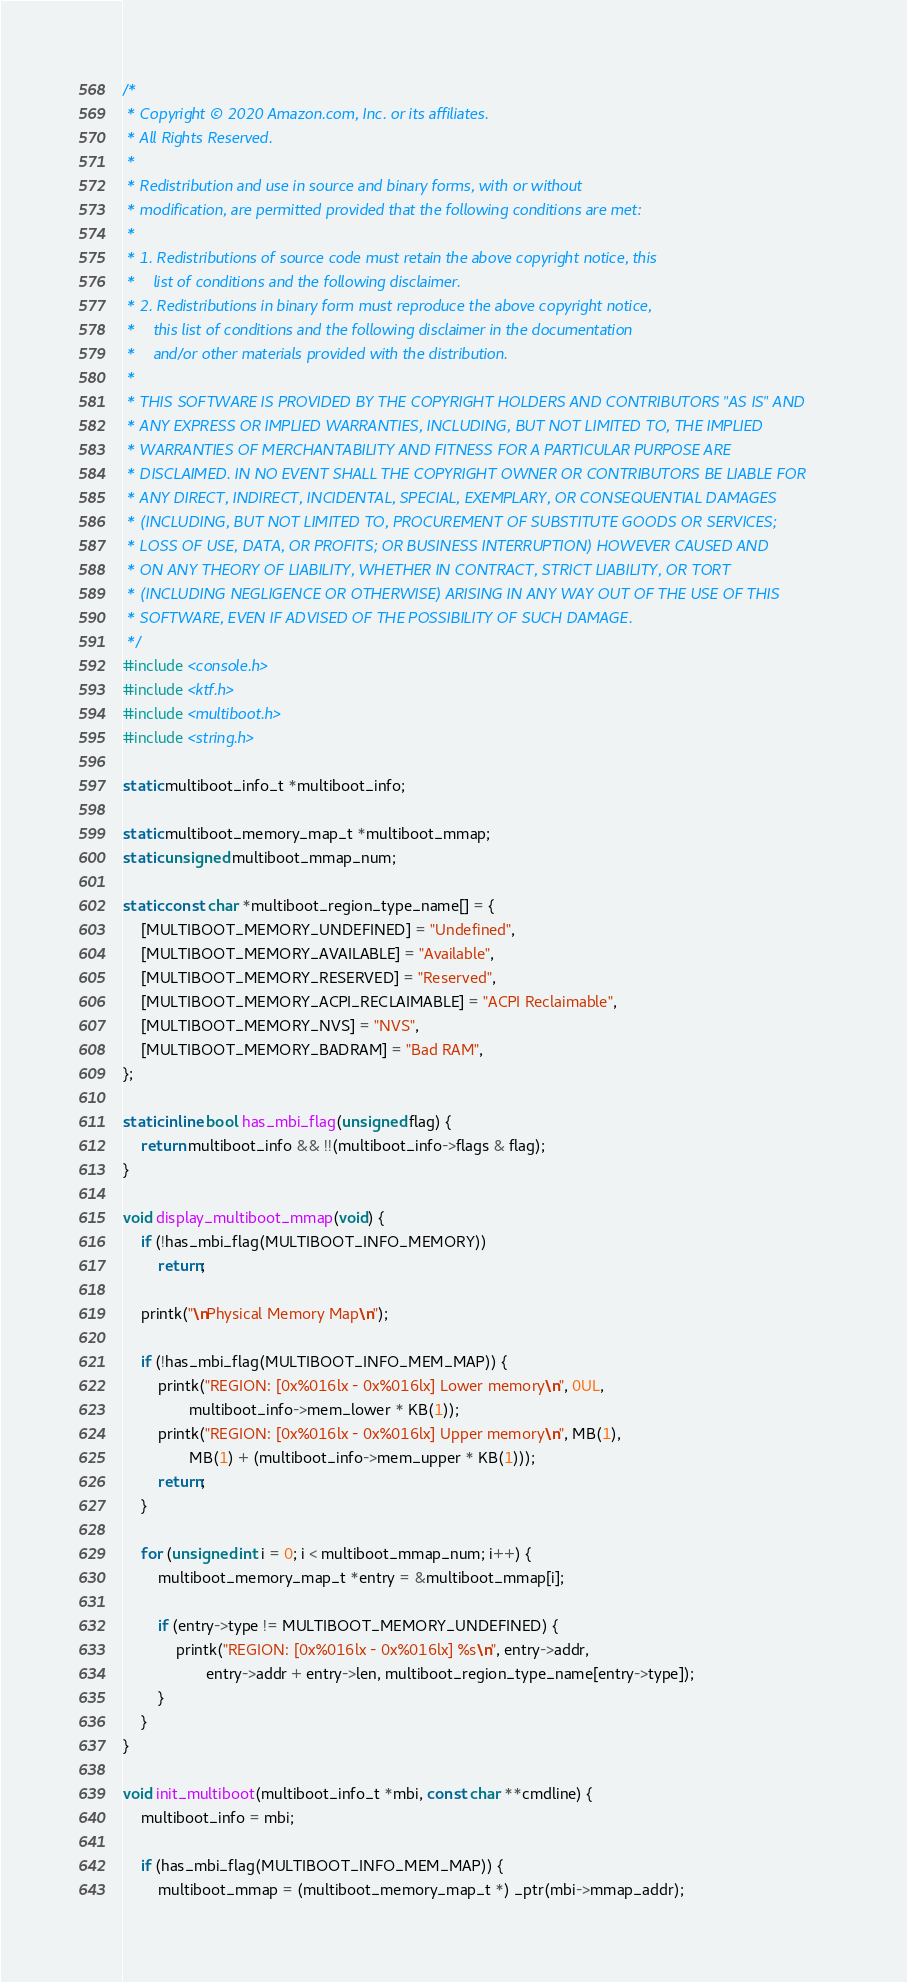Convert code to text. <code><loc_0><loc_0><loc_500><loc_500><_C_>/*
 * Copyright © 2020 Amazon.com, Inc. or its affiliates.
 * All Rights Reserved.
 *
 * Redistribution and use in source and binary forms, with or without
 * modification, are permitted provided that the following conditions are met:
 *
 * 1. Redistributions of source code must retain the above copyright notice, this
 *    list of conditions and the following disclaimer.
 * 2. Redistributions in binary form must reproduce the above copyright notice,
 *    this list of conditions and the following disclaimer in the documentation
 *    and/or other materials provided with the distribution.
 *
 * THIS SOFTWARE IS PROVIDED BY THE COPYRIGHT HOLDERS AND CONTRIBUTORS "AS IS" AND
 * ANY EXPRESS OR IMPLIED WARRANTIES, INCLUDING, BUT NOT LIMITED TO, THE IMPLIED
 * WARRANTIES OF MERCHANTABILITY AND FITNESS FOR A PARTICULAR PURPOSE ARE
 * DISCLAIMED. IN NO EVENT SHALL THE COPYRIGHT OWNER OR CONTRIBUTORS BE LIABLE FOR
 * ANY DIRECT, INDIRECT, INCIDENTAL, SPECIAL, EXEMPLARY, OR CONSEQUENTIAL DAMAGES
 * (INCLUDING, BUT NOT LIMITED TO, PROCUREMENT OF SUBSTITUTE GOODS OR SERVICES;
 * LOSS OF USE, DATA, OR PROFITS; OR BUSINESS INTERRUPTION) HOWEVER CAUSED AND
 * ON ANY THEORY OF LIABILITY, WHETHER IN CONTRACT, STRICT LIABILITY, OR TORT
 * (INCLUDING NEGLIGENCE OR OTHERWISE) ARISING IN ANY WAY OUT OF THE USE OF THIS
 * SOFTWARE, EVEN IF ADVISED OF THE POSSIBILITY OF SUCH DAMAGE.
 */
#include <console.h>
#include <ktf.h>
#include <multiboot.h>
#include <string.h>

static multiboot_info_t *multiboot_info;

static multiboot_memory_map_t *multiboot_mmap;
static unsigned multiboot_mmap_num;

static const char *multiboot_region_type_name[] = {
    [MULTIBOOT_MEMORY_UNDEFINED] = "Undefined",
    [MULTIBOOT_MEMORY_AVAILABLE] = "Available",
    [MULTIBOOT_MEMORY_RESERVED] = "Reserved",
    [MULTIBOOT_MEMORY_ACPI_RECLAIMABLE] = "ACPI Reclaimable",
    [MULTIBOOT_MEMORY_NVS] = "NVS",
    [MULTIBOOT_MEMORY_BADRAM] = "Bad RAM",
};

static inline bool has_mbi_flag(unsigned flag) {
    return multiboot_info && !!(multiboot_info->flags & flag);
}

void display_multiboot_mmap(void) {
    if (!has_mbi_flag(MULTIBOOT_INFO_MEMORY))
        return;

    printk("\nPhysical Memory Map\n");

    if (!has_mbi_flag(MULTIBOOT_INFO_MEM_MAP)) {
        printk("REGION: [0x%016lx - 0x%016lx] Lower memory\n", 0UL,
               multiboot_info->mem_lower * KB(1));
        printk("REGION: [0x%016lx - 0x%016lx] Upper memory\n", MB(1),
               MB(1) + (multiboot_info->mem_upper * KB(1)));
        return;
    }

    for (unsigned int i = 0; i < multiboot_mmap_num; i++) {
        multiboot_memory_map_t *entry = &multiboot_mmap[i];

        if (entry->type != MULTIBOOT_MEMORY_UNDEFINED) {
            printk("REGION: [0x%016lx - 0x%016lx] %s\n", entry->addr,
                   entry->addr + entry->len, multiboot_region_type_name[entry->type]);
        }
    }
}

void init_multiboot(multiboot_info_t *mbi, const char **cmdline) {
    multiboot_info = mbi;

    if (has_mbi_flag(MULTIBOOT_INFO_MEM_MAP)) {
        multiboot_mmap = (multiboot_memory_map_t *) _ptr(mbi->mmap_addr);</code> 